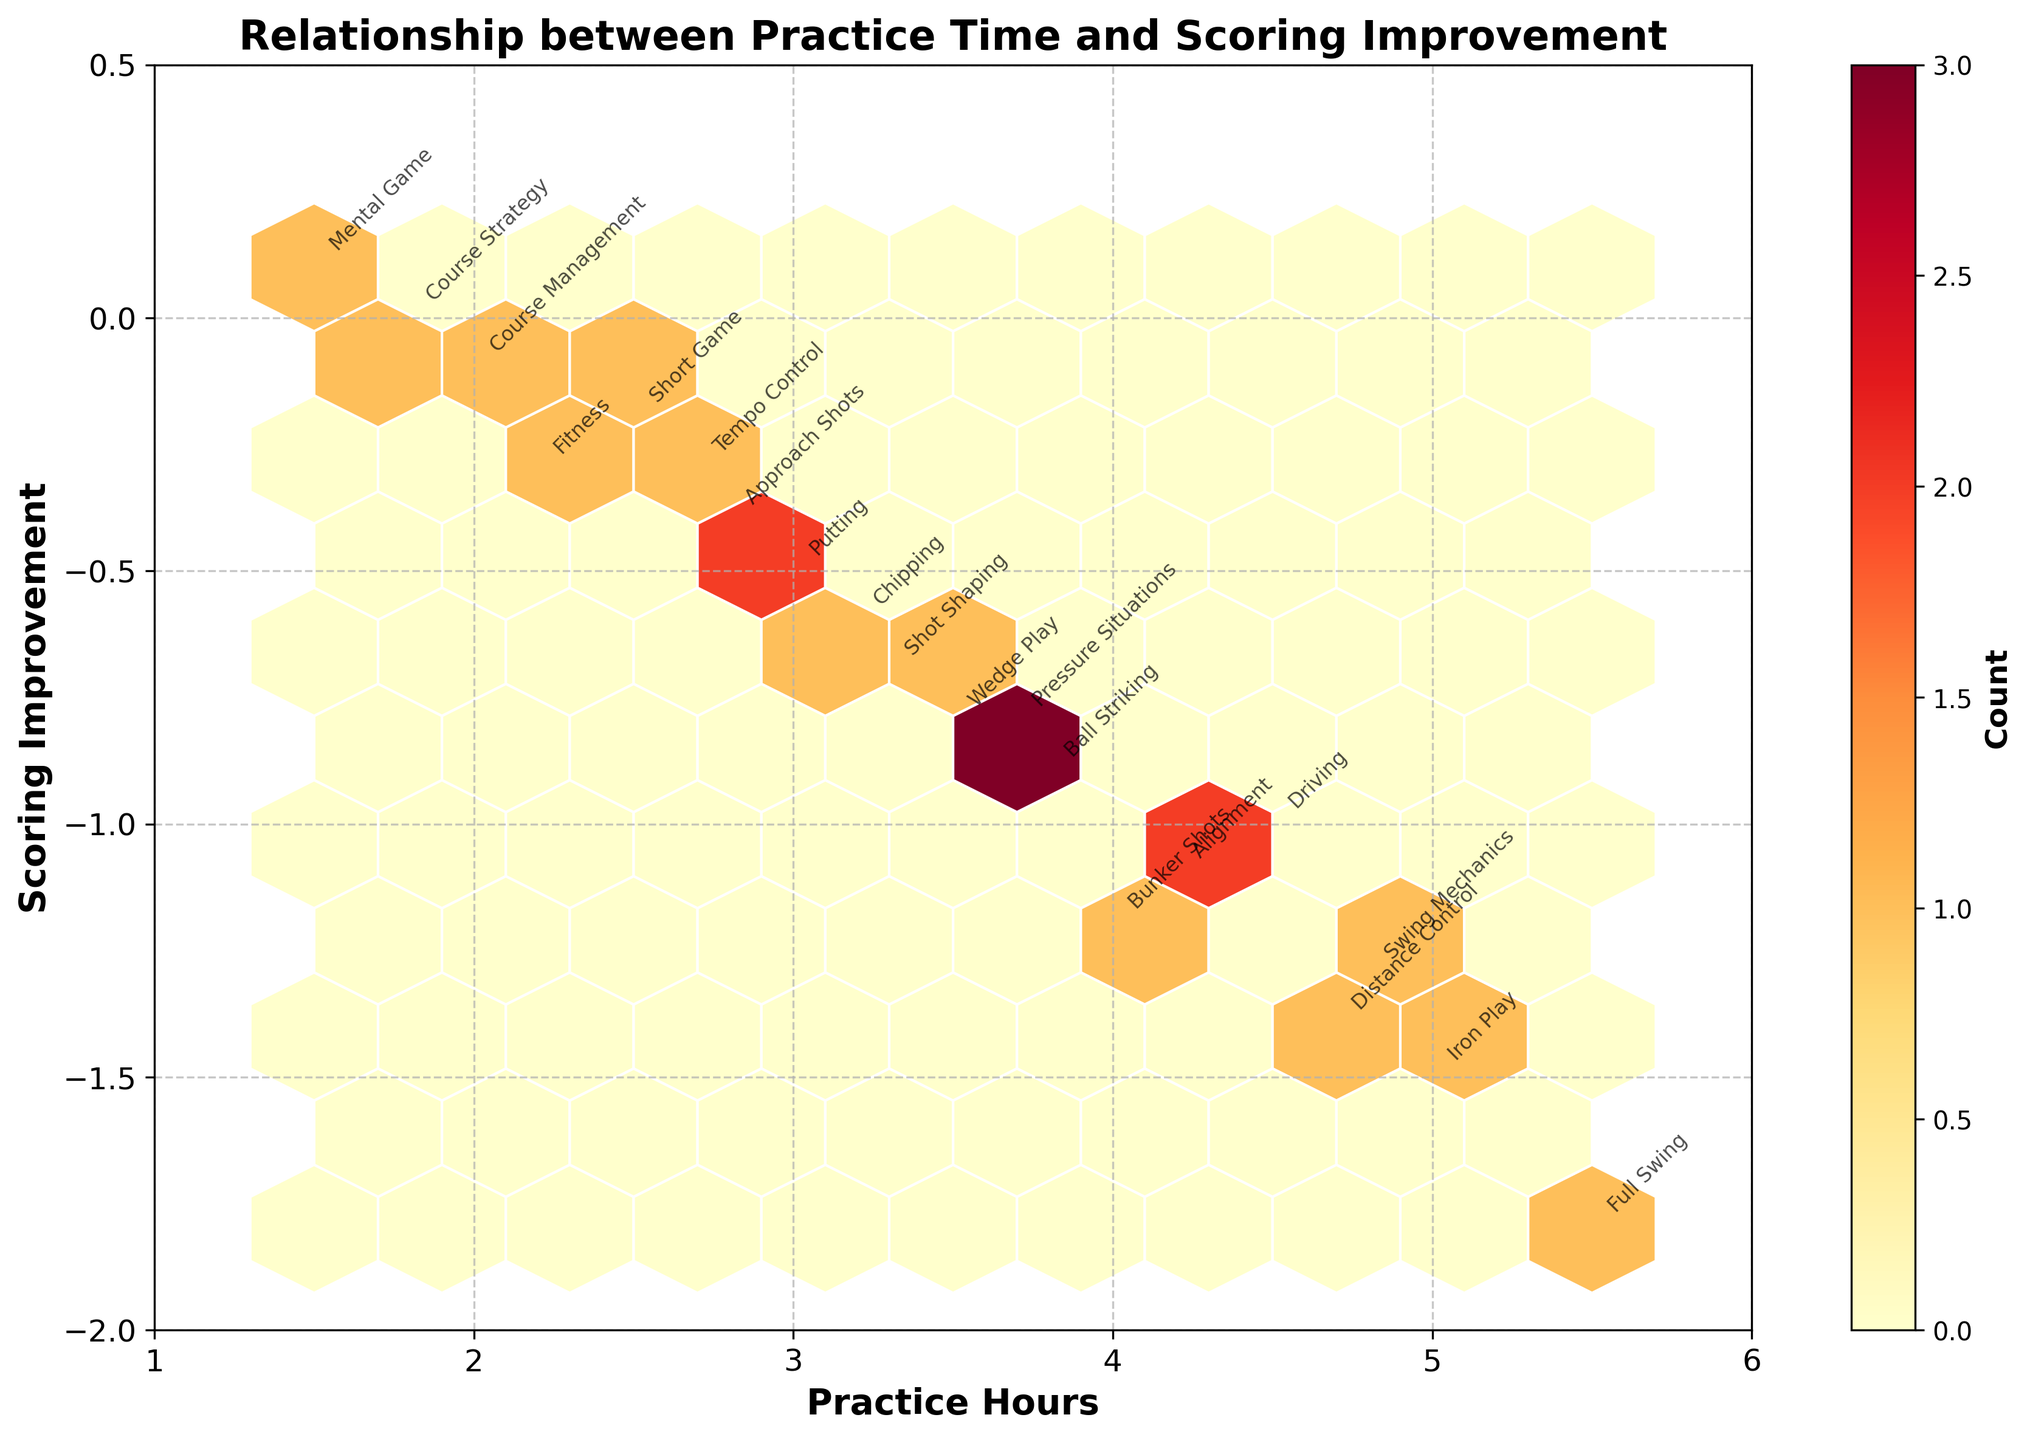What is the title of the figure? The title is located at the top of the figure. It usually provides a summary of what the chart is about.
Answer: Relationship between Practice Time and Scoring Improvement What is the range of practice hours displayed on the x-axis? The x-axis shows the range of practice hours. Observing the axis values, the range is clear.
Answer: 1 to 6 Where is the highest concentration of data points? Identifying the hexbin that has the darkest color or the highest density helps locate the highest concentration of data points. The color bar indicates 'count'.
Answer: Between 3 and 4 practice hours and scoring improvements between -0.6 and -1.0 Which training focus has the highest scoring improvement? Annotated text labels next to the hexagonal bins show training focus. The point with the lowest value on the y-axis represents the highest scoring improvement.
Answer: Full Swing How many training focuses are annotated in the plot? Counting each unique annotated label helps determine the number of training focuses represented in the plot.
Answer: 20 What is the scoring improvement for Wedge Play? Locating the annotation for 'Wedge Play' and reading the y-value associated with it helps identify the scoring improvement.
Answer: -0.8 Which data point has the lowest Practice Hours and what is its scoring improvement? By locating the point with the lowest x-axis value and referring to the closest annotation, you can identify the training focus and its scoring improvement.
Answer: Mental Game, 0.1 Compare the scoring improvements between 'Iron Play' and 'Fitness' practice focuses. By locating the annotated text labels for 'Iron Play' and 'Fitness' and referencing their associated y-values, the scoring improvements can be compared.
Answer: Iron Play: -1.5, Fitness: -0.3. Iron Play has a greater improvement Which practice focus falls closest to 3 practice hours and what is its scoring improvement? Observing the data points around the 3 practice hours mark and locating the closest annotated training focus provides the relevant information.
Answer: Chipping, -0.6 What is the range of scoring improvement for practice hours between 4 and 5? Observing the hexbin plot for the data points within 4 and 5 practice hours on the x-axis and examining the respective y-values provides the scoring improvement range.
Answer: -1.5 to -1.0 